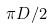Convert formula to latex. <formula><loc_0><loc_0><loc_500><loc_500>\pi D / 2</formula> 